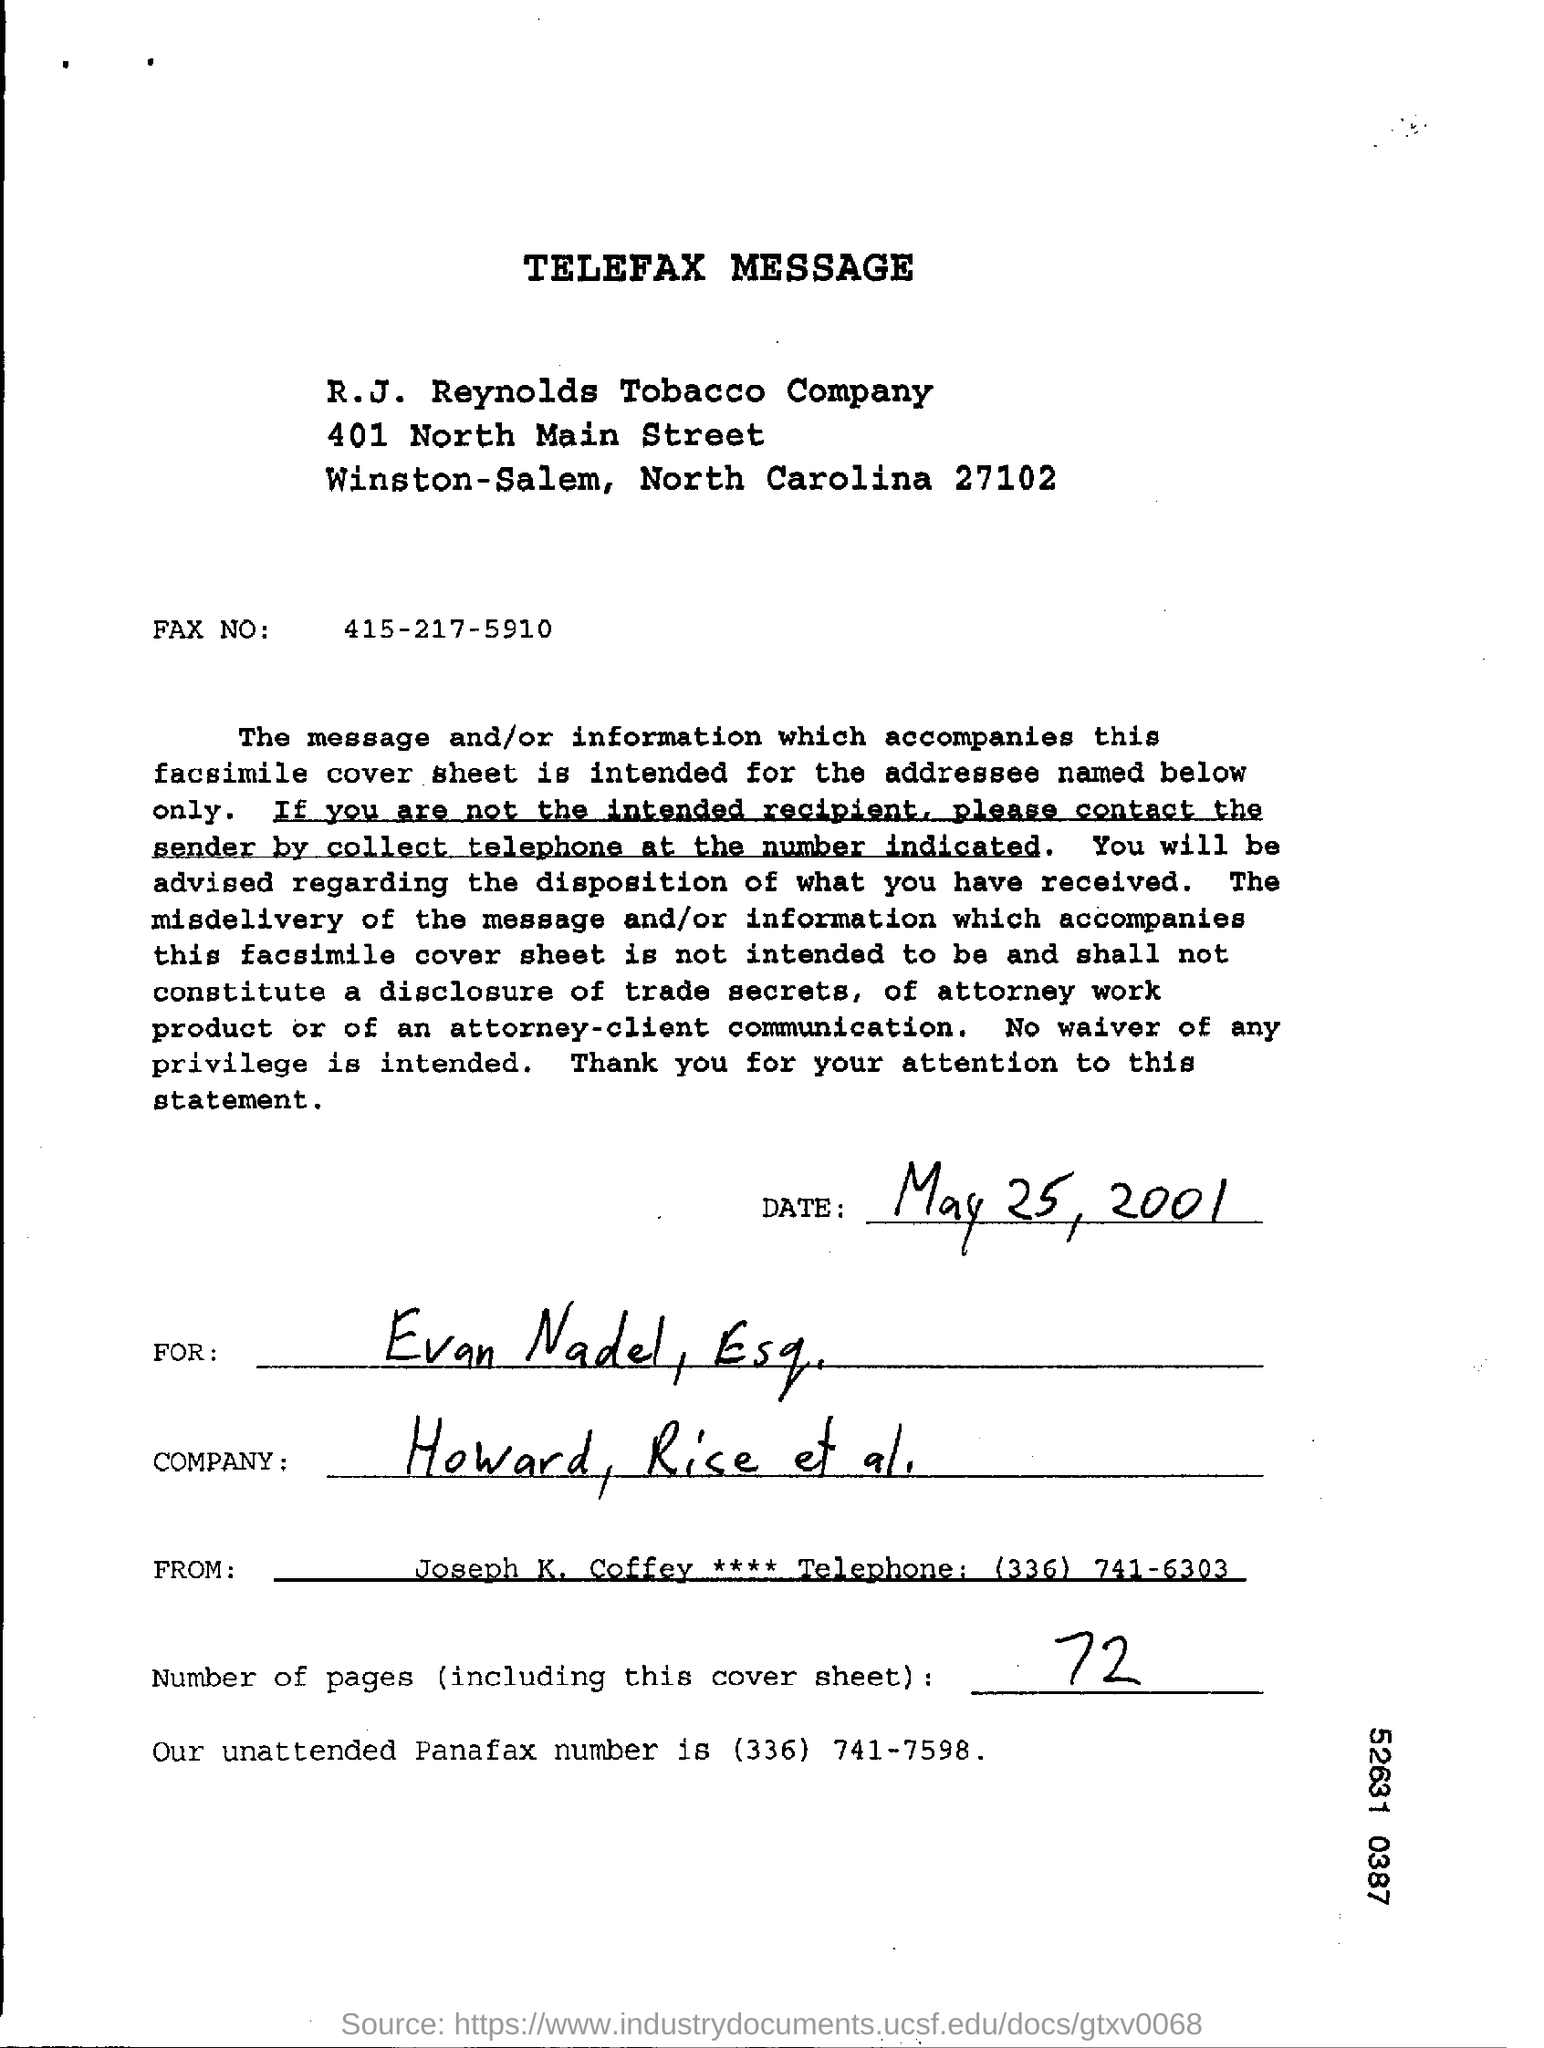What kind of document is this?
Your answer should be compact. Telefax message. What is the date mentioned in this document?
Provide a succinct answer. May 25, 2001. Who is the sender of telefax message?
Make the answer very short. Joseph K. Coffey. Who is the receiver of the Telefax message?
Give a very brief answer. Evan nadel , esq. How many pages are available including this cover sheet?
Your answer should be very brief. 72. What is the unattended panafax number mentioned?
Offer a terse response. (336) 741-7598. 